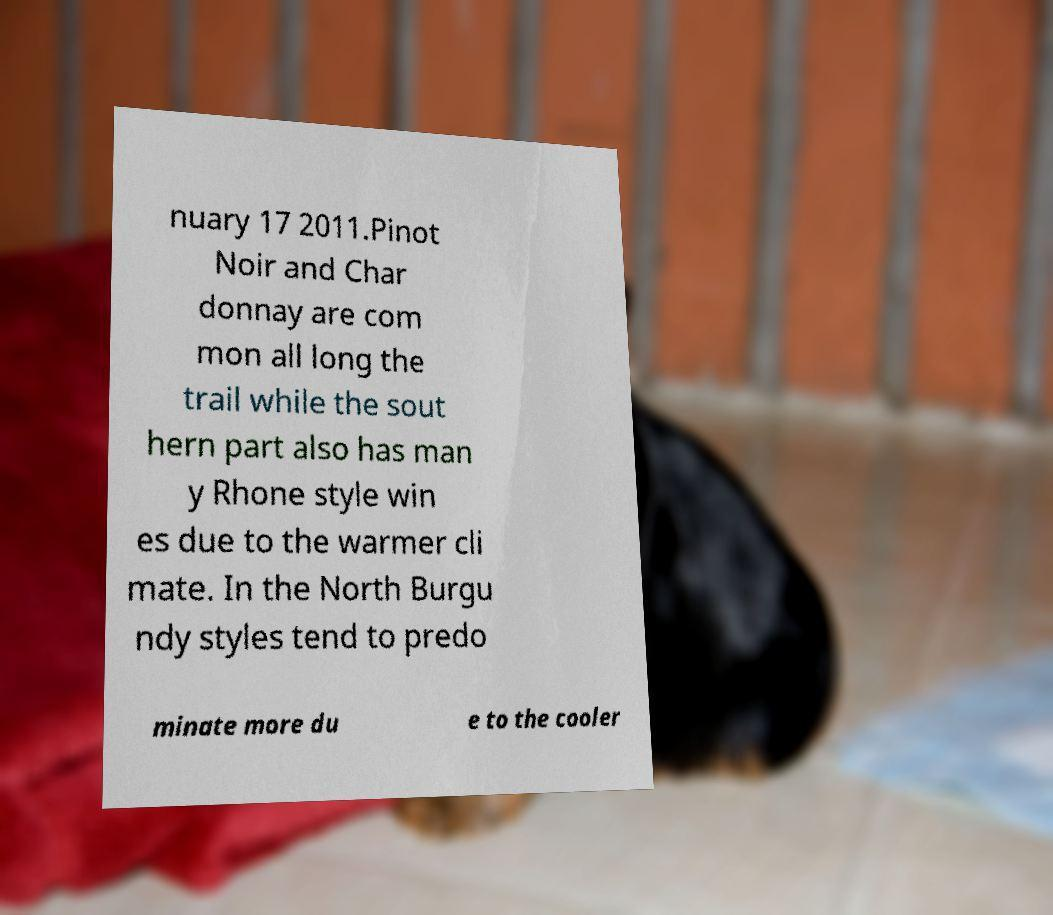For documentation purposes, I need the text within this image transcribed. Could you provide that? nuary 17 2011.Pinot Noir and Char donnay are com mon all long the trail while the sout hern part also has man y Rhone style win es due to the warmer cli mate. In the North Burgu ndy styles tend to predo minate more du e to the cooler 